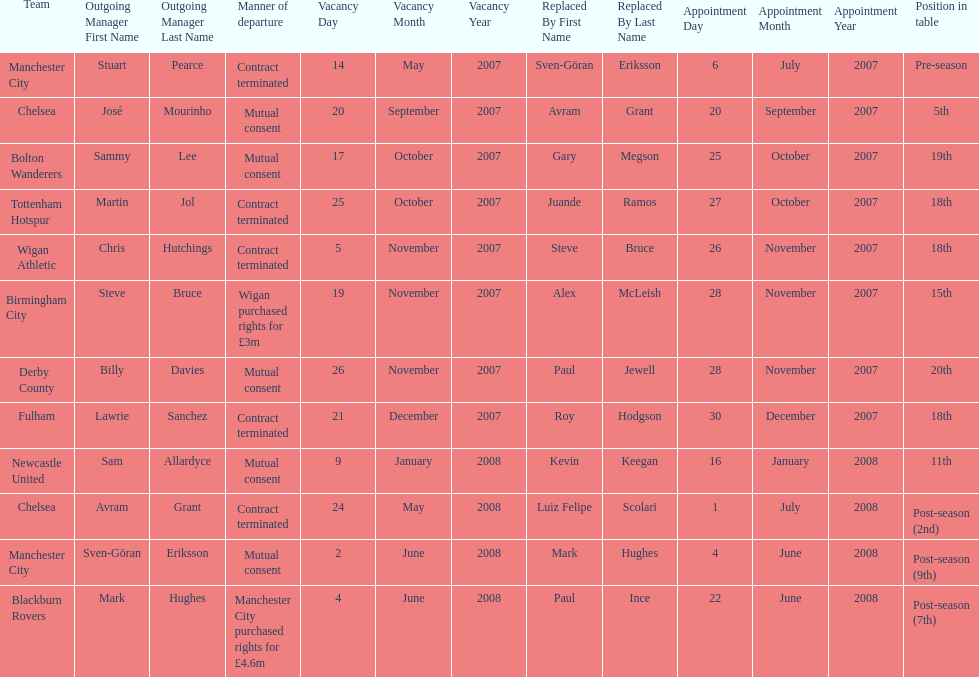What was the only team to place 5th called? Chelsea. 